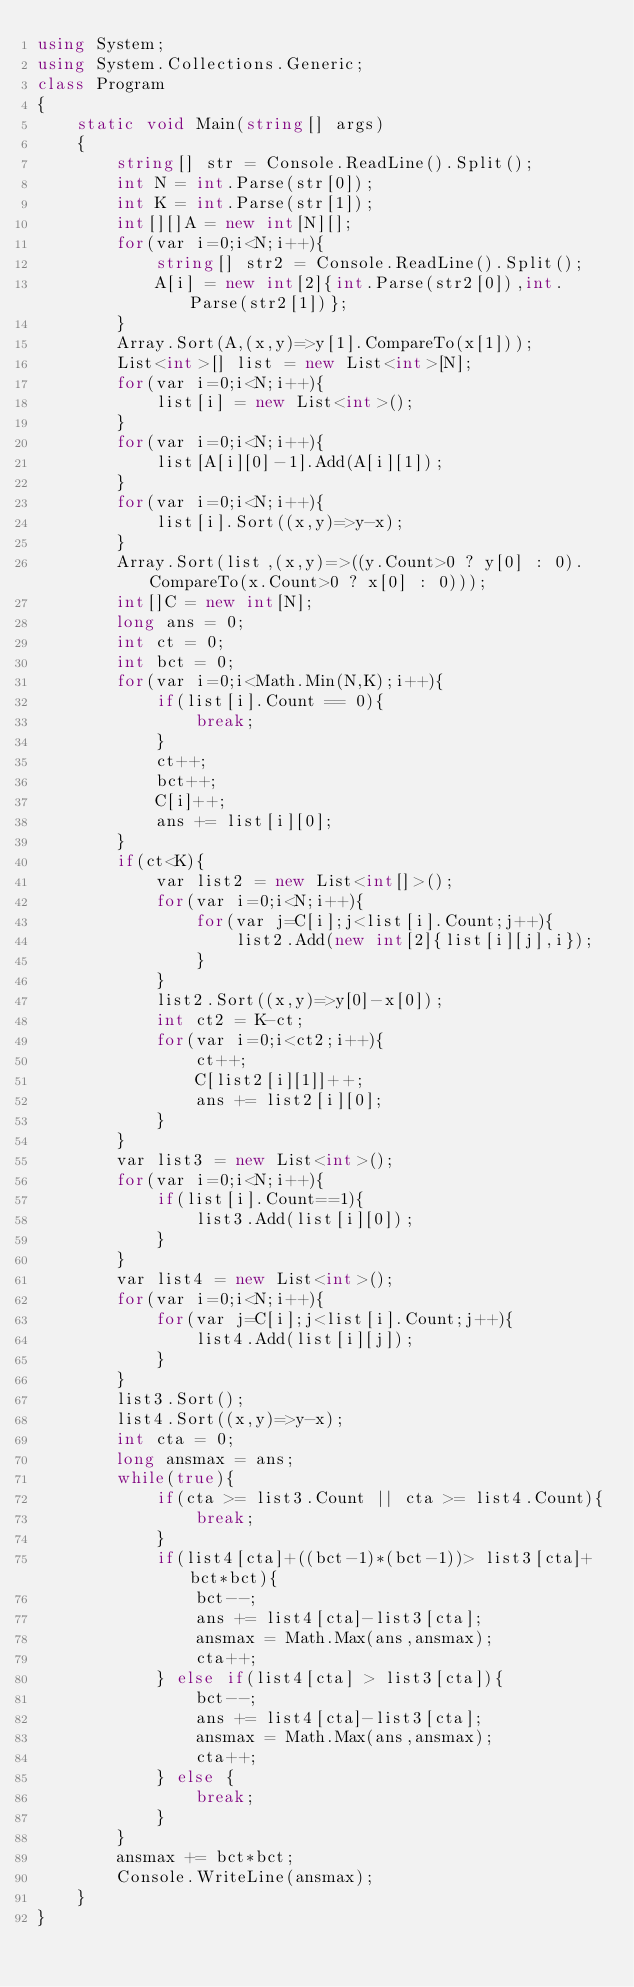<code> <loc_0><loc_0><loc_500><loc_500><_C#_>using System;
using System.Collections.Generic;
class Program
{
	static void Main(string[] args)
	{
		string[] str = Console.ReadLine().Split();
		int N = int.Parse(str[0]);
		int K = int.Parse(str[1]);
		int[][]A = new int[N][];
		for(var i=0;i<N;i++){
			string[] str2 = Console.ReadLine().Split();
			A[i] = new int[2]{int.Parse(str2[0]),int.Parse(str2[1])};
		}
		Array.Sort(A,(x,y)=>y[1].CompareTo(x[1]));
		List<int>[] list = new List<int>[N];
		for(var i=0;i<N;i++){
			list[i] = new List<int>();
		}
		for(var i=0;i<N;i++){
			list[A[i][0]-1].Add(A[i][1]);
		}
		for(var i=0;i<N;i++){
			list[i].Sort((x,y)=>y-x);
		}
		Array.Sort(list,(x,y)=>((y.Count>0 ? y[0] : 0).CompareTo(x.Count>0 ? x[0] : 0)));
		int[]C = new int[N];
		long ans = 0;
		int ct = 0;
		int bct = 0;
		for(var i=0;i<Math.Min(N,K);i++){
			if(list[i].Count == 0){
				break;
			}
			ct++;
			bct++;
			C[i]++;
			ans += list[i][0];
		}
		if(ct<K){
			var list2 = new List<int[]>();
			for(var i=0;i<N;i++){
				for(var j=C[i];j<list[i].Count;j++){
					list2.Add(new int[2]{list[i][j],i});
				}
			}
			list2.Sort((x,y)=>y[0]-x[0]);
			int ct2 = K-ct;
			for(var i=0;i<ct2;i++){
				ct++;
				C[list2[i][1]]++;
				ans += list2[i][0];
			}
		}
		var list3 = new List<int>();
		for(var i=0;i<N;i++){
			if(list[i].Count==1){
				list3.Add(list[i][0]);
			}
		}
		var list4 = new List<int>();
		for(var i=0;i<N;i++){
			for(var j=C[i];j<list[i].Count;j++){
				list4.Add(list[i][j]);
			}
		}
		list3.Sort();
		list4.Sort((x,y)=>y-x);
		int cta = 0;
		long ansmax = ans;
		while(true){
			if(cta >= list3.Count || cta >= list4.Count){
				break;
			}
			if(list4[cta]+((bct-1)*(bct-1))> list3[cta]+bct*bct){
				bct--;
				ans += list4[cta]-list3[cta];
				ansmax = Math.Max(ans,ansmax);
				cta++;
			} else if(list4[cta] > list3[cta]){
				bct--;
				ans += list4[cta]-list3[cta];
				ansmax = Math.Max(ans,ansmax);
				cta++;
			} else {
				break;
			}
		}
		ansmax += bct*bct;
		Console.WriteLine(ansmax);
	}
}</code> 